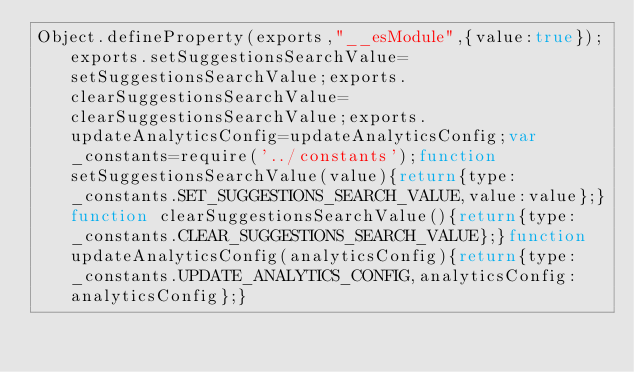<code> <loc_0><loc_0><loc_500><loc_500><_JavaScript_>Object.defineProperty(exports,"__esModule",{value:true});exports.setSuggestionsSearchValue=setSuggestionsSearchValue;exports.clearSuggestionsSearchValue=clearSuggestionsSearchValue;exports.updateAnalyticsConfig=updateAnalyticsConfig;var _constants=require('../constants');function setSuggestionsSearchValue(value){return{type:_constants.SET_SUGGESTIONS_SEARCH_VALUE,value:value};}function clearSuggestionsSearchValue(){return{type:_constants.CLEAR_SUGGESTIONS_SEARCH_VALUE};}function updateAnalyticsConfig(analyticsConfig){return{type:_constants.UPDATE_ANALYTICS_CONFIG,analyticsConfig:analyticsConfig};}</code> 